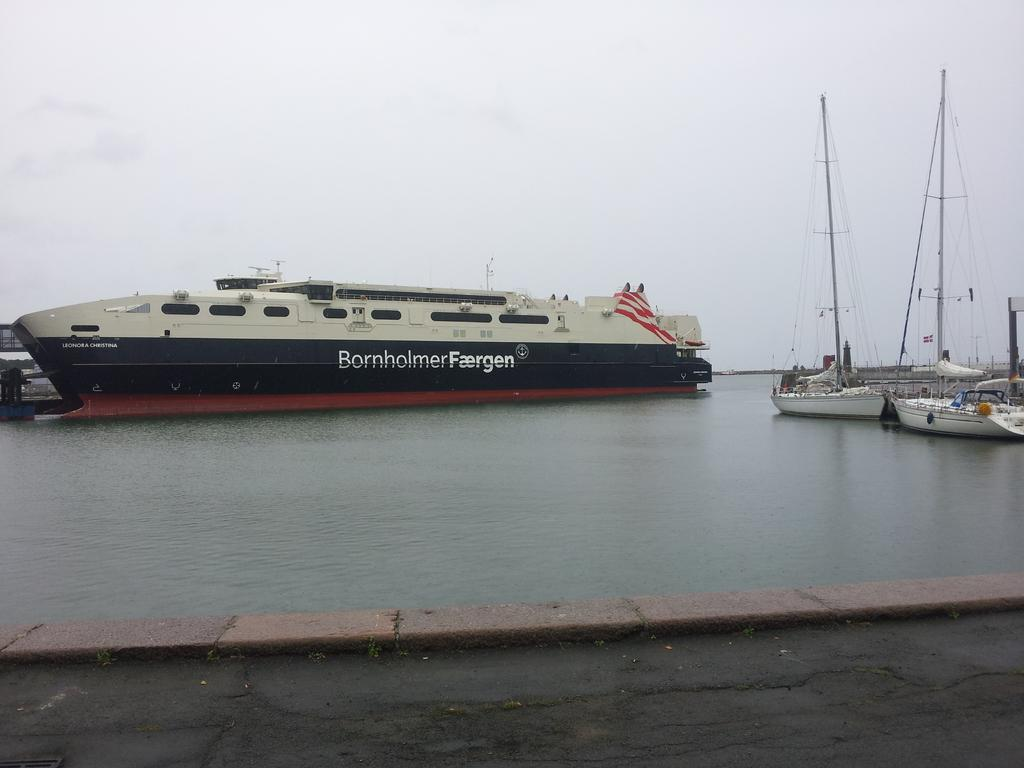<image>
Create a compact narrative representing the image presented. a ship reading Bornholmers Faergen in a harbor 